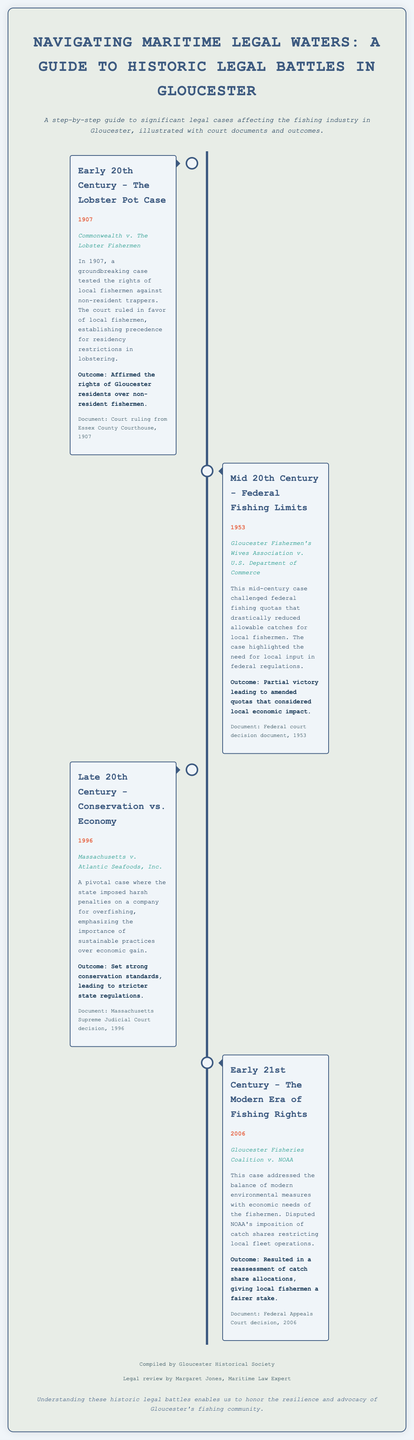What is the title of the document? The title is presented prominently at the top of the infographic, summarizing its focus on legal battles in Gloucester.
Answer: Navigating Maritime Legal Waters: A Guide to Historic Legal Battles in Gloucester What was the outcome of the Lobster Pot Case? The outcome section summarizes the ruling from the case, indicating its significance for local fishermen.
Answer: Affirmed the rights of Gloucester residents over non-resident fishermen In what year did the Gloucester Fishermen's Wives Association case occur? The document provides specific years associated with each significant legal case listed in the timeline.
Answer: 1953 Which case emphasized sustainable practices over economic gain? This question requires identifying the case that focused on conservation efforts as opposed to profit.
Answer: Massachusetts v. Atlantic Seafoods, Inc What organization was involved in the 2006 case? This question asks for the important party identified in the court case mentioned for that year.
Answer: NOAA What was the focus of the timeline structure in the document? The layout illustrates the significant legal cases and their historical context through a linear representation.
Answer: Historic legal battles affecting the fishing industry How many significant legal cases are presented in the infographic? This question prompts a count of the distinct legal battles analyzed in the document.
Answer: Four What type of document is this infographic intending to represent? This question seeks to clarify the nature of the information being presented through the visual format.
Answer: Process infographic What was a major reason for the 1953 case? This question looks for the specific challenge raised against federal regulations in that legal situation.
Answer: Federal fishing quotas What did the 1996 case result in? This question targets the outcome and its implications resulting from the indicated court decision.
Answer: Set strong conservation standards, leading to stricter state regulations 